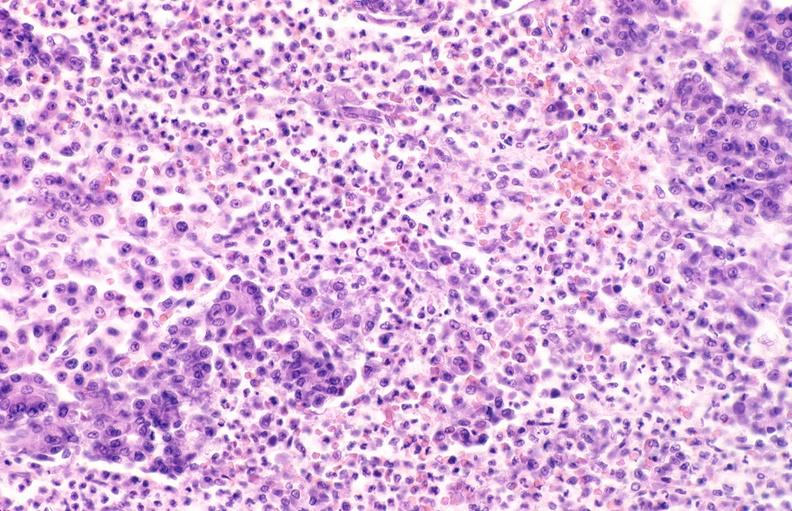does section of spleen through hilum show pancreatic fat necrosis?
Answer the question using a single word or phrase. No 